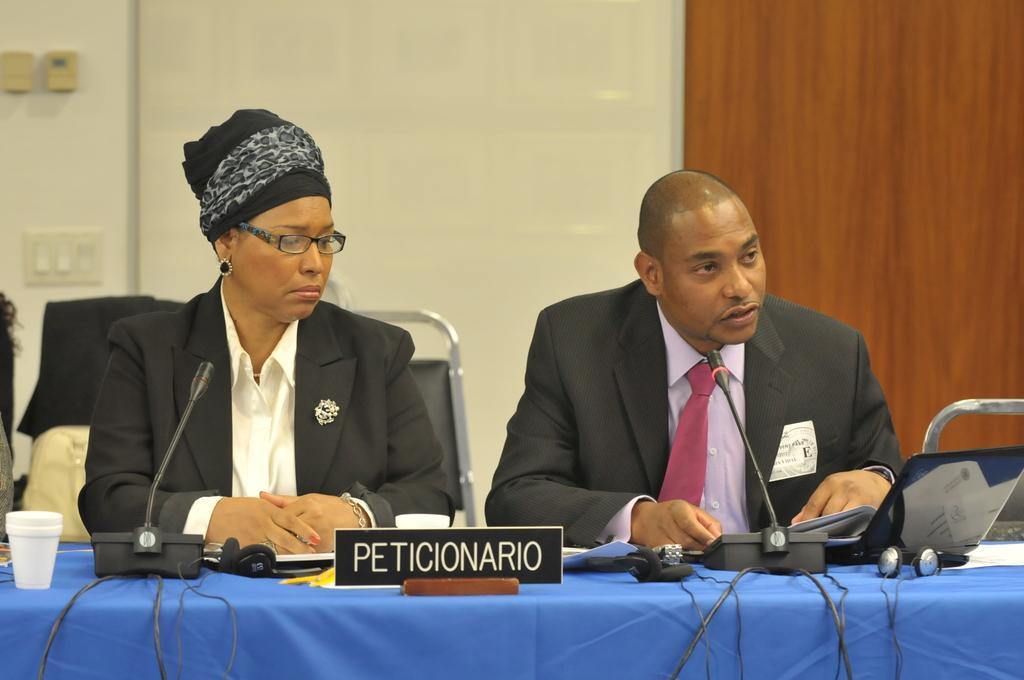Can you describe this image briefly? In this picture we can see two people sitting on the chair. There is a cup, microphones, laptop, headsets and other objects on the table. We can see white objects and a wooden object in the background. 